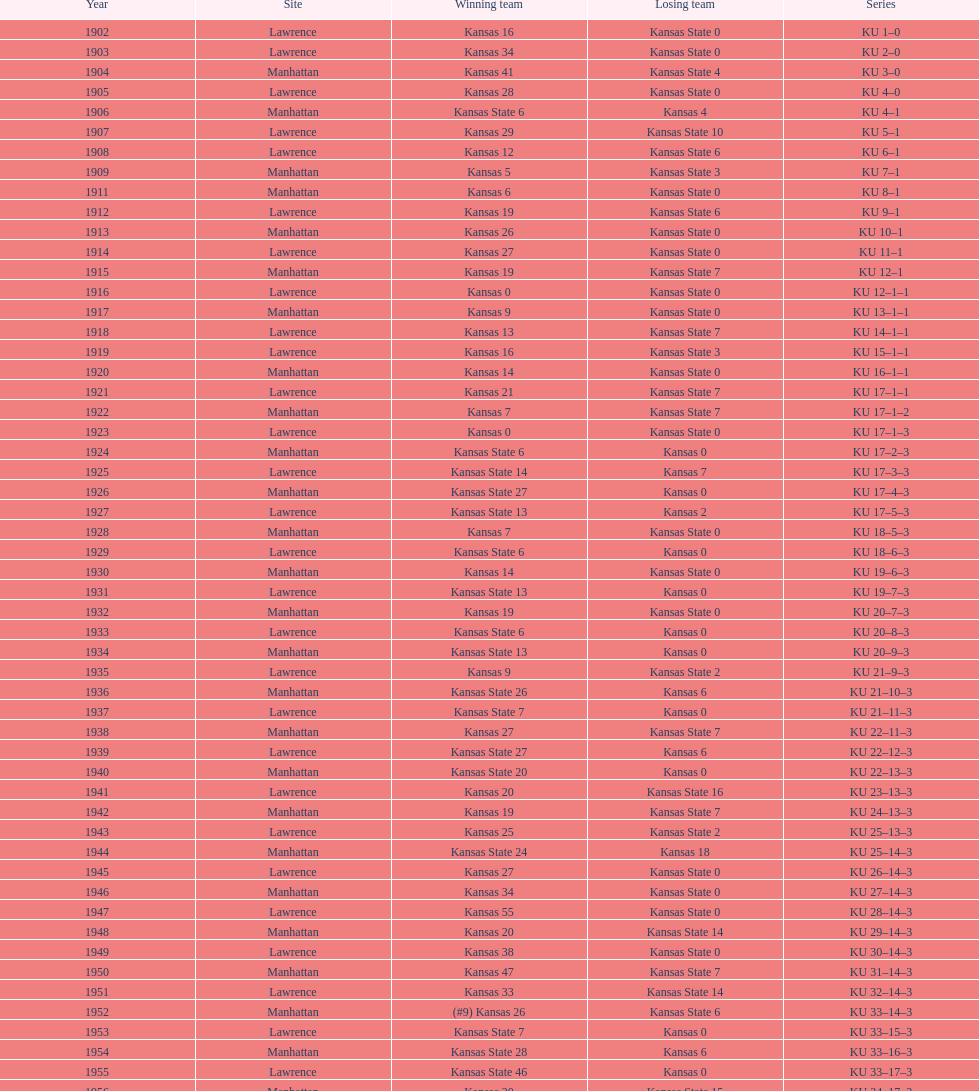How many times did kansas state not score at all against kansas from 1902-1968? 23. 